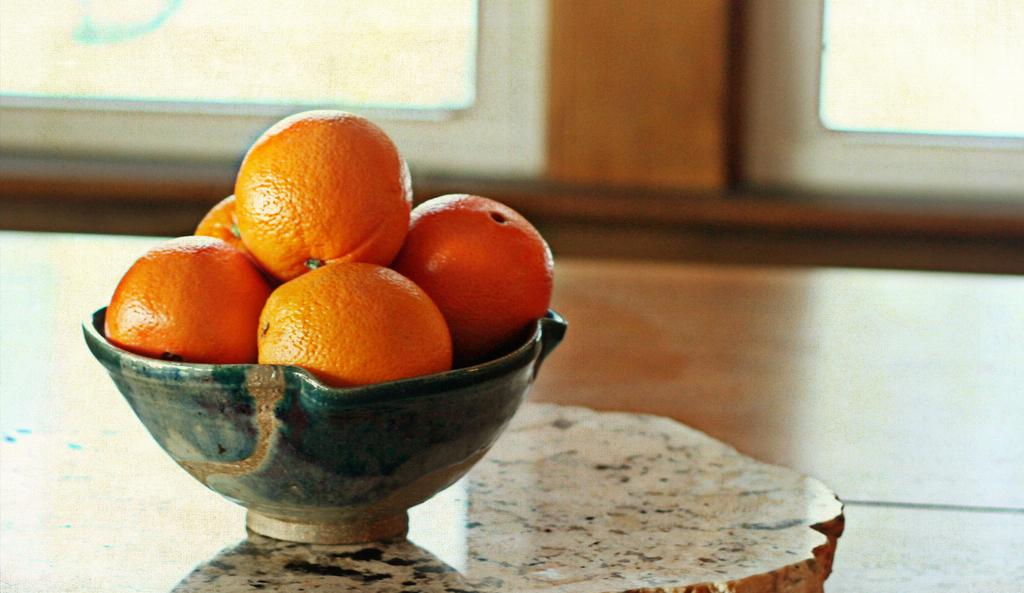What is in the bowl that is visible in the image? There is a bowl of oranges in the image. Where is the bowl of oranges located in the image? The bowl of oranges is on the left side of the image. What can be seen at the top side of the image? There are windows at the top side of the image. How many clocks are visible on the shelf in the image? There is no shelf or clocks present in the image. 